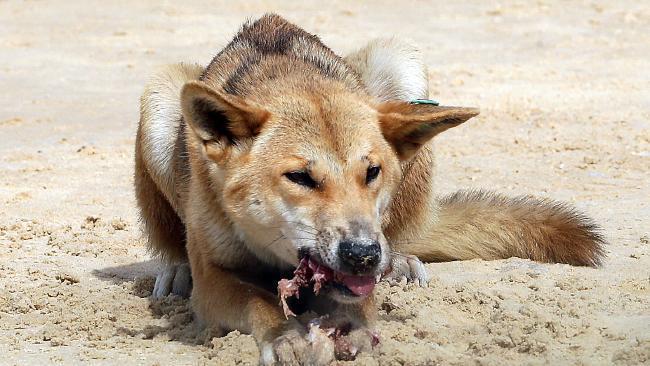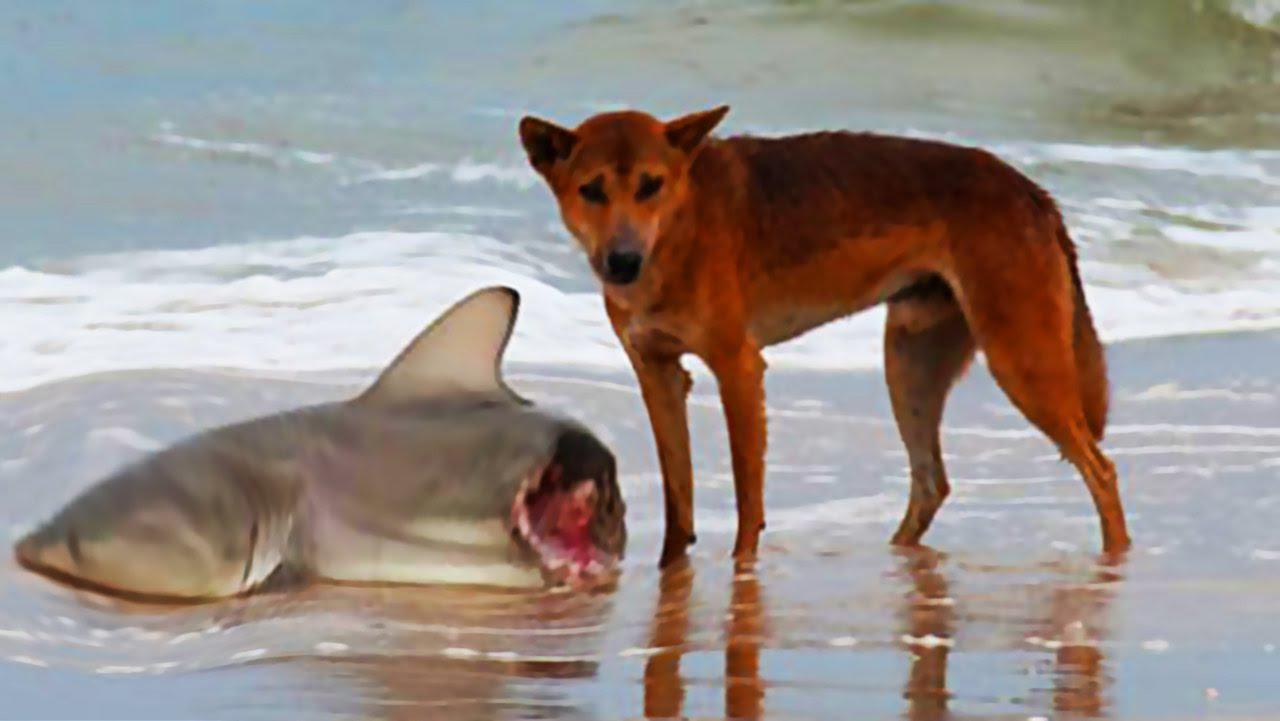The first image is the image on the left, the second image is the image on the right. Examine the images to the left and right. Is the description "A wild dog is standing near a half eaten shark in the image on the right." accurate? Answer yes or no. Yes. 